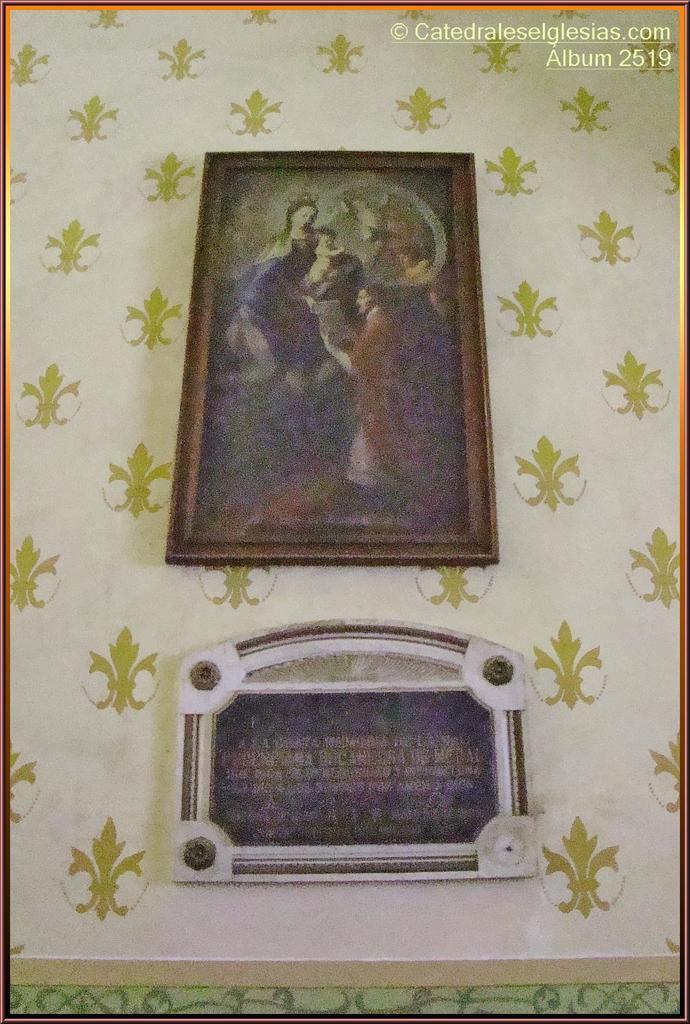How would you summarize this image in a sentence or two? In this picture there are two photo frames attached on a designed wall and there is something written in the right top corner. 